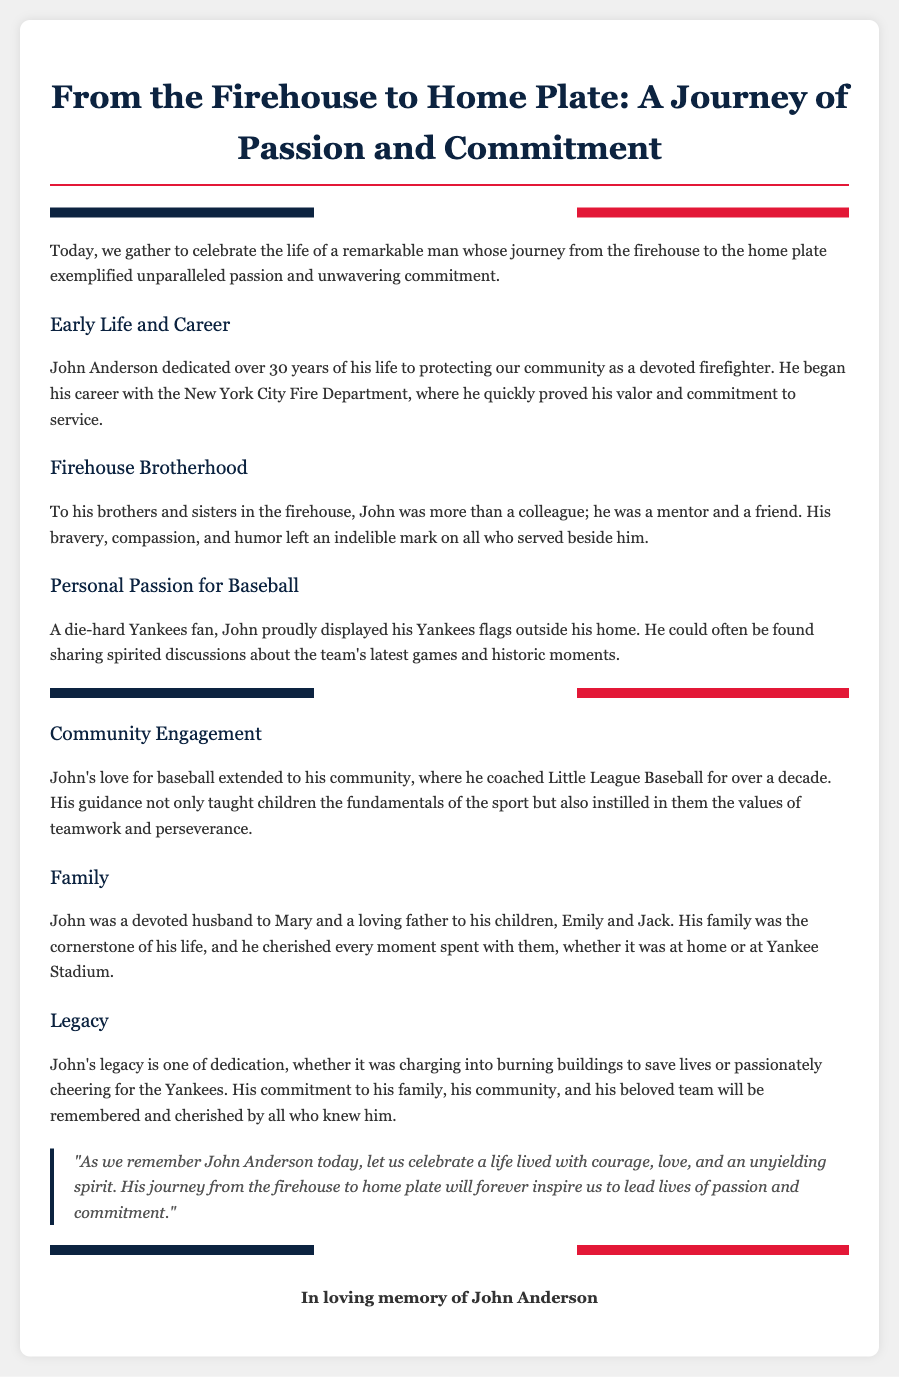What was John Anderson's profession? John Anderson dedicated over 30 years of his life to protecting the community as a devoted firefighter.
Answer: firefighter What team did John Anderson support? John Anderson was a die-hard Yankees fan, which shows his support for the team.
Answer: Yankees How many years did John coach Little League Baseball? John coached Little League Baseball for over a decade, indicating his long-term commitment.
Answer: over a decade What was the title of the eulogy? The title of the eulogy highlights John Anderson's journey and his passions.
Answer: From the Firehouse to Home Plate: A Journey of Passion and Commitment Who was John Anderson's wife? The document mentions that John was a devoted husband to Mary.
Answer: Mary What values did John instill in the children he coached? The document states that John instilled the values of teamwork and perseverance.
Answer: teamwork and perseverance What does the quote in the document emphasize? The quote reflects on remembering John Anderson's life with courage, love, and spirit.
Answer: courage, love, and spirit In which city did John serve as a firefighter? John began his career with the New York City Fire Department, indicating the location of his service.
Answer: New York City What color are the Yankees' flags mentioned in the eulogy? The flags represent the Yankees and feature their team colors, specifically mentioned in their display.
Answer: blue, white, red 